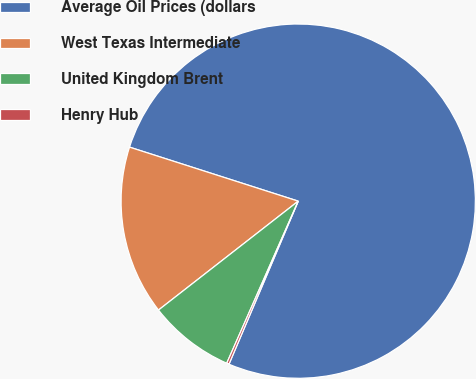<chart> <loc_0><loc_0><loc_500><loc_500><pie_chart><fcel>Average Oil Prices (dollars<fcel>West Texas Intermediate<fcel>United Kingdom Brent<fcel>Henry Hub<nl><fcel>76.46%<fcel>15.47%<fcel>7.85%<fcel>0.22%<nl></chart> 